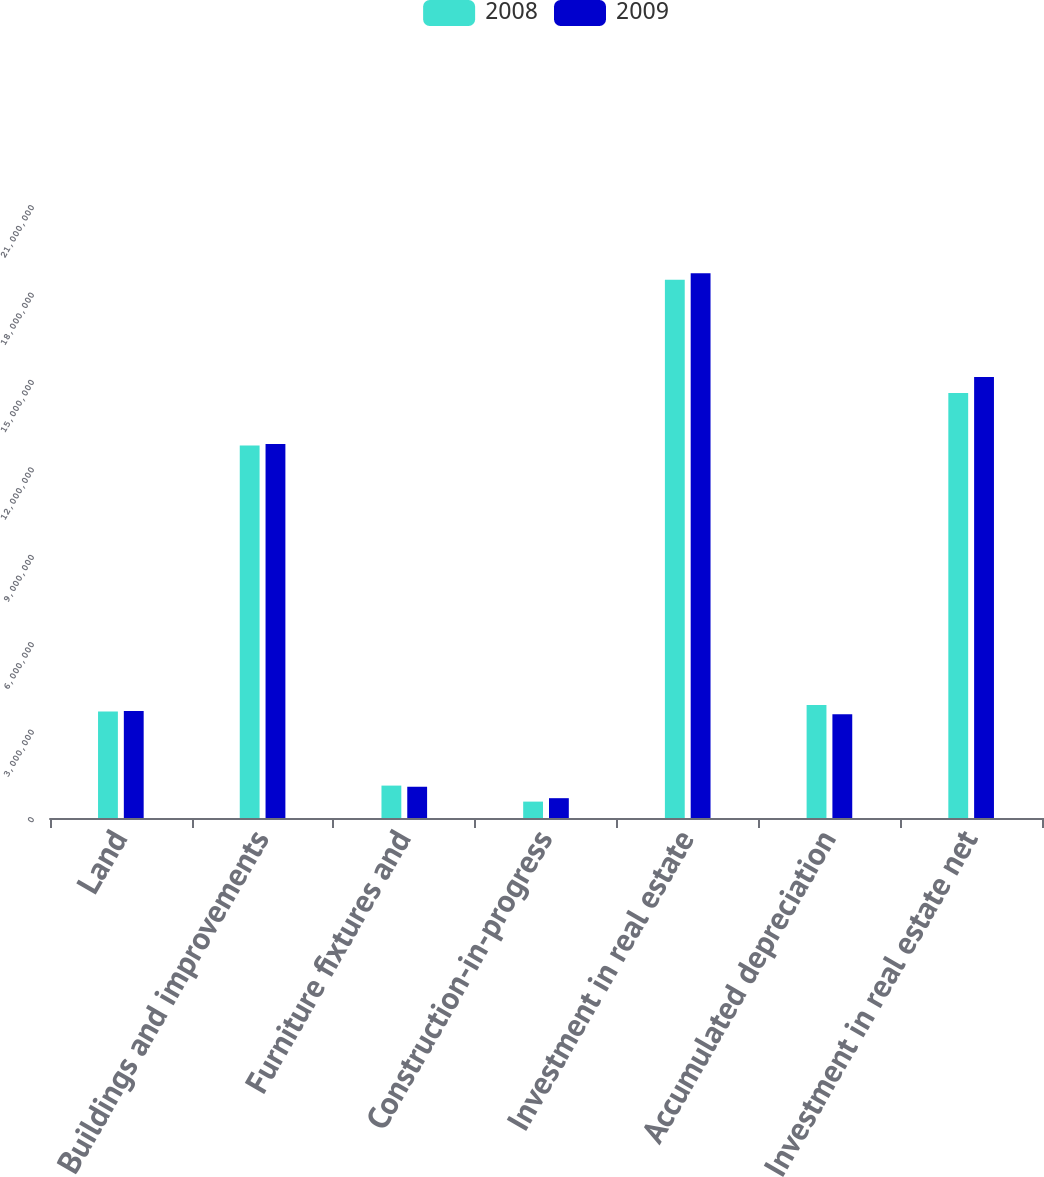Convert chart. <chart><loc_0><loc_0><loc_500><loc_500><stacked_bar_chart><ecel><fcel>Land<fcel>Buildings and improvements<fcel>Furniture fixtures and<fcel>Construction-in-progress<fcel>Investment in real estate<fcel>Accumulated depreciation<fcel>Investment in real estate net<nl><fcel>2008<fcel>3.65032e+06<fcel>1.27815e+07<fcel>1.11198e+06<fcel>562263<fcel>1.84651e+07<fcel>3.87756e+06<fcel>1.45876e+07<nl><fcel>2009<fcel>3.6713e+06<fcel>1.28363e+07<fcel>1.07228e+06<fcel>680118<fcel>1.86902e+07<fcel>3.5613e+06<fcel>1.51289e+07<nl></chart> 